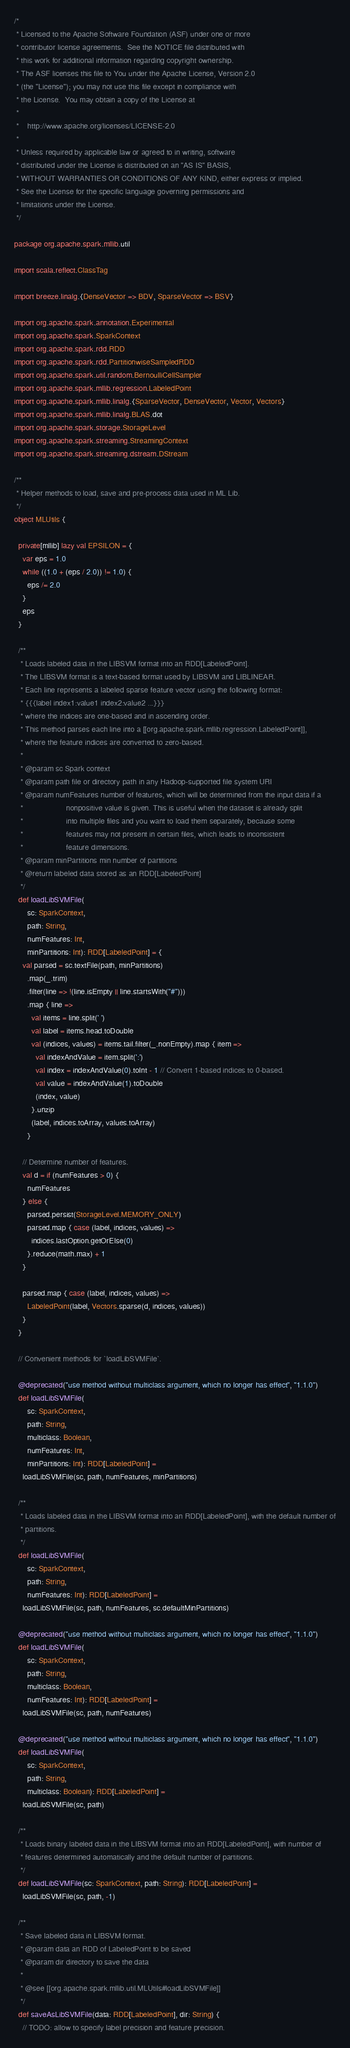<code> <loc_0><loc_0><loc_500><loc_500><_Scala_>/*
 * Licensed to the Apache Software Foundation (ASF) under one or more
 * contributor license agreements.  See the NOTICE file distributed with
 * this work for additional information regarding copyright ownership.
 * The ASF licenses this file to You under the Apache License, Version 2.0
 * (the "License"); you may not use this file except in compliance with
 * the License.  You may obtain a copy of the License at
 *
 *    http://www.apache.org/licenses/LICENSE-2.0
 *
 * Unless required by applicable law or agreed to in writing, software
 * distributed under the License is distributed on an "AS IS" BASIS,
 * WITHOUT WARRANTIES OR CONDITIONS OF ANY KIND, either express or implied.
 * See the License for the specific language governing permissions and
 * limitations under the License.
 */

package org.apache.spark.mllib.util

import scala.reflect.ClassTag

import breeze.linalg.{DenseVector => BDV, SparseVector => BSV}

import org.apache.spark.annotation.Experimental
import org.apache.spark.SparkContext
import org.apache.spark.rdd.RDD
import org.apache.spark.rdd.PartitionwiseSampledRDD
import org.apache.spark.util.random.BernoulliCellSampler
import org.apache.spark.mllib.regression.LabeledPoint
import org.apache.spark.mllib.linalg.{SparseVector, DenseVector, Vector, Vectors}
import org.apache.spark.mllib.linalg.BLAS.dot
import org.apache.spark.storage.StorageLevel
import org.apache.spark.streaming.StreamingContext
import org.apache.spark.streaming.dstream.DStream

/**
 * Helper methods to load, save and pre-process data used in ML Lib.
 */
object MLUtils {

  private[mllib] lazy val EPSILON = {
    var eps = 1.0
    while ((1.0 + (eps / 2.0)) != 1.0) {
      eps /= 2.0
    }
    eps
  }

  /**
   * Loads labeled data in the LIBSVM format into an RDD[LabeledPoint].
   * The LIBSVM format is a text-based format used by LIBSVM and LIBLINEAR.
   * Each line represents a labeled sparse feature vector using the following format:
   * {{{label index1:value1 index2:value2 ...}}}
   * where the indices are one-based and in ascending order.
   * This method parses each line into a [[org.apache.spark.mllib.regression.LabeledPoint]],
   * where the feature indices are converted to zero-based.
   *
   * @param sc Spark context
   * @param path file or directory path in any Hadoop-supported file system URI
   * @param numFeatures number of features, which will be determined from the input data if a
   *                    nonpositive value is given. This is useful when the dataset is already split
   *                    into multiple files and you want to load them separately, because some
   *                    features may not present in certain files, which leads to inconsistent
   *                    feature dimensions.
   * @param minPartitions min number of partitions
   * @return labeled data stored as an RDD[LabeledPoint]
   */
  def loadLibSVMFile(
      sc: SparkContext,
      path: String,
      numFeatures: Int,
      minPartitions: Int): RDD[LabeledPoint] = {
    val parsed = sc.textFile(path, minPartitions)
      .map(_.trim)
      .filter(line => !(line.isEmpty || line.startsWith("#")))
      .map { line =>
        val items = line.split(' ')
        val label = items.head.toDouble
        val (indices, values) = items.tail.filter(_.nonEmpty).map { item =>
          val indexAndValue = item.split(':')
          val index = indexAndValue(0).toInt - 1 // Convert 1-based indices to 0-based.
          val value = indexAndValue(1).toDouble
          (index, value)
        }.unzip
        (label, indices.toArray, values.toArray)
      }

    // Determine number of features.
    val d = if (numFeatures > 0) {
      numFeatures
    } else {
      parsed.persist(StorageLevel.MEMORY_ONLY)
      parsed.map { case (label, indices, values) =>
        indices.lastOption.getOrElse(0)
      }.reduce(math.max) + 1
    }

    parsed.map { case (label, indices, values) =>
      LabeledPoint(label, Vectors.sparse(d, indices, values))
    }
  }

  // Convenient methods for `loadLibSVMFile`.

  @deprecated("use method without multiclass argument, which no longer has effect", "1.1.0")
  def loadLibSVMFile(
      sc: SparkContext,
      path: String,
      multiclass: Boolean,
      numFeatures: Int,
      minPartitions: Int): RDD[LabeledPoint] =
    loadLibSVMFile(sc, path, numFeatures, minPartitions)

  /**
   * Loads labeled data in the LIBSVM format into an RDD[LabeledPoint], with the default number of
   * partitions.
   */
  def loadLibSVMFile(
      sc: SparkContext,
      path: String,
      numFeatures: Int): RDD[LabeledPoint] =
    loadLibSVMFile(sc, path, numFeatures, sc.defaultMinPartitions)

  @deprecated("use method without multiclass argument, which no longer has effect", "1.1.0")
  def loadLibSVMFile(
      sc: SparkContext,
      path: String,
      multiclass: Boolean,
      numFeatures: Int): RDD[LabeledPoint] =
    loadLibSVMFile(sc, path, numFeatures)

  @deprecated("use method without multiclass argument, which no longer has effect", "1.1.0")
  def loadLibSVMFile(
      sc: SparkContext,
      path: String,
      multiclass: Boolean): RDD[LabeledPoint] =
    loadLibSVMFile(sc, path)

  /**
   * Loads binary labeled data in the LIBSVM format into an RDD[LabeledPoint], with number of
   * features determined automatically and the default number of partitions.
   */
  def loadLibSVMFile(sc: SparkContext, path: String): RDD[LabeledPoint] =
    loadLibSVMFile(sc, path, -1)

  /**
   * Save labeled data in LIBSVM format.
   * @param data an RDD of LabeledPoint to be saved
   * @param dir directory to save the data
   *
   * @see [[org.apache.spark.mllib.util.MLUtils#loadLibSVMFile]]
   */
  def saveAsLibSVMFile(data: RDD[LabeledPoint], dir: String) {
    // TODO: allow to specify label precision and feature precision.</code> 